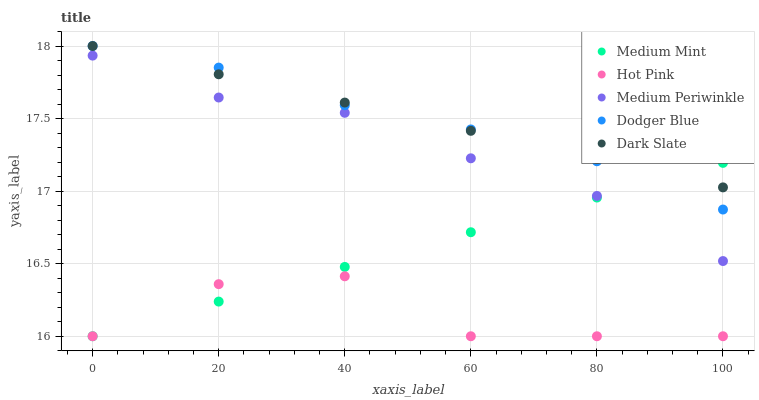Does Hot Pink have the minimum area under the curve?
Answer yes or no. Yes. Does Dark Slate have the maximum area under the curve?
Answer yes or no. Yes. Does Dodger Blue have the minimum area under the curve?
Answer yes or no. No. Does Dodger Blue have the maximum area under the curve?
Answer yes or no. No. Is Medium Mint the smoothest?
Answer yes or no. Yes. Is Hot Pink the roughest?
Answer yes or no. Yes. Is Dodger Blue the smoothest?
Answer yes or no. No. Is Dodger Blue the roughest?
Answer yes or no. No. Does Medium Mint have the lowest value?
Answer yes or no. Yes. Does Dodger Blue have the lowest value?
Answer yes or no. No. Does Dark Slate have the highest value?
Answer yes or no. Yes. Does Hot Pink have the highest value?
Answer yes or no. No. Is Hot Pink less than Dodger Blue?
Answer yes or no. Yes. Is Dodger Blue greater than Medium Periwinkle?
Answer yes or no. Yes. Does Dodger Blue intersect Dark Slate?
Answer yes or no. Yes. Is Dodger Blue less than Dark Slate?
Answer yes or no. No. Is Dodger Blue greater than Dark Slate?
Answer yes or no. No. Does Hot Pink intersect Dodger Blue?
Answer yes or no. No. 